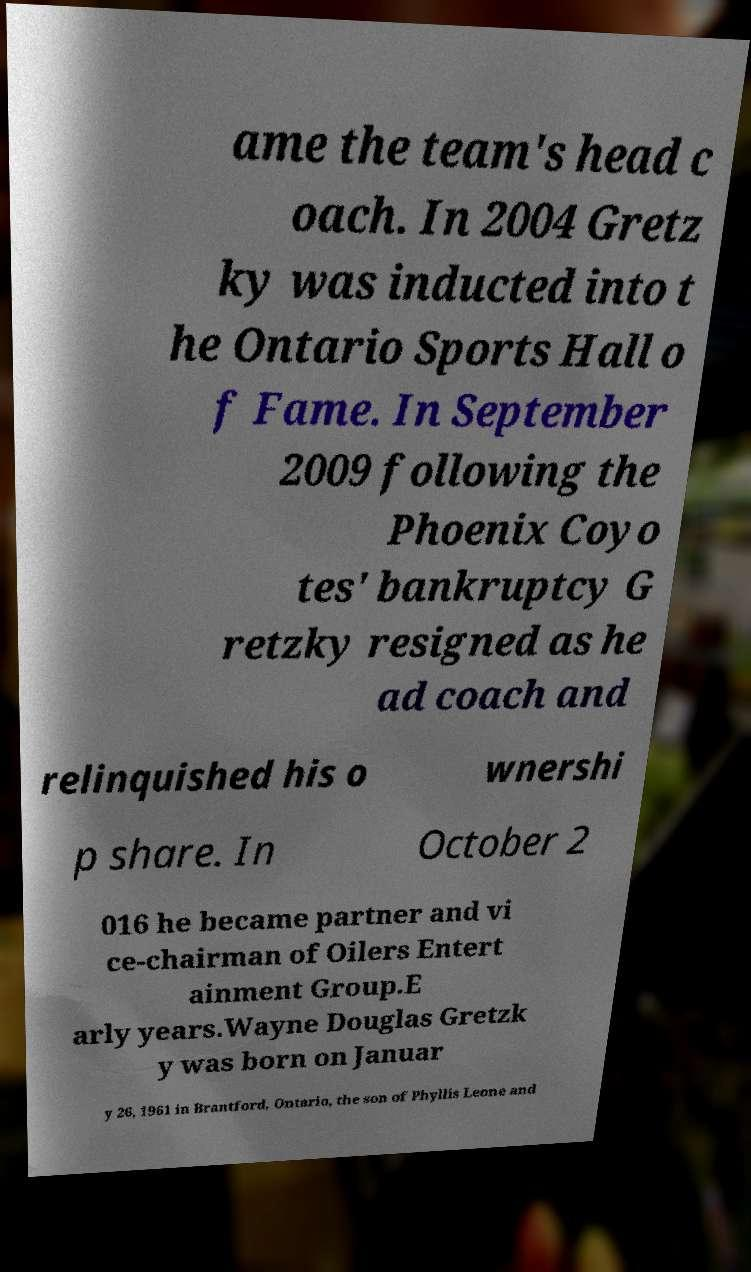Could you assist in decoding the text presented in this image and type it out clearly? ame the team's head c oach. In 2004 Gretz ky was inducted into t he Ontario Sports Hall o f Fame. In September 2009 following the Phoenix Coyo tes' bankruptcy G retzky resigned as he ad coach and relinquished his o wnershi p share. In October 2 016 he became partner and vi ce-chairman of Oilers Entert ainment Group.E arly years.Wayne Douglas Gretzk y was born on Januar y 26, 1961 in Brantford, Ontario, the son of Phyllis Leone and 